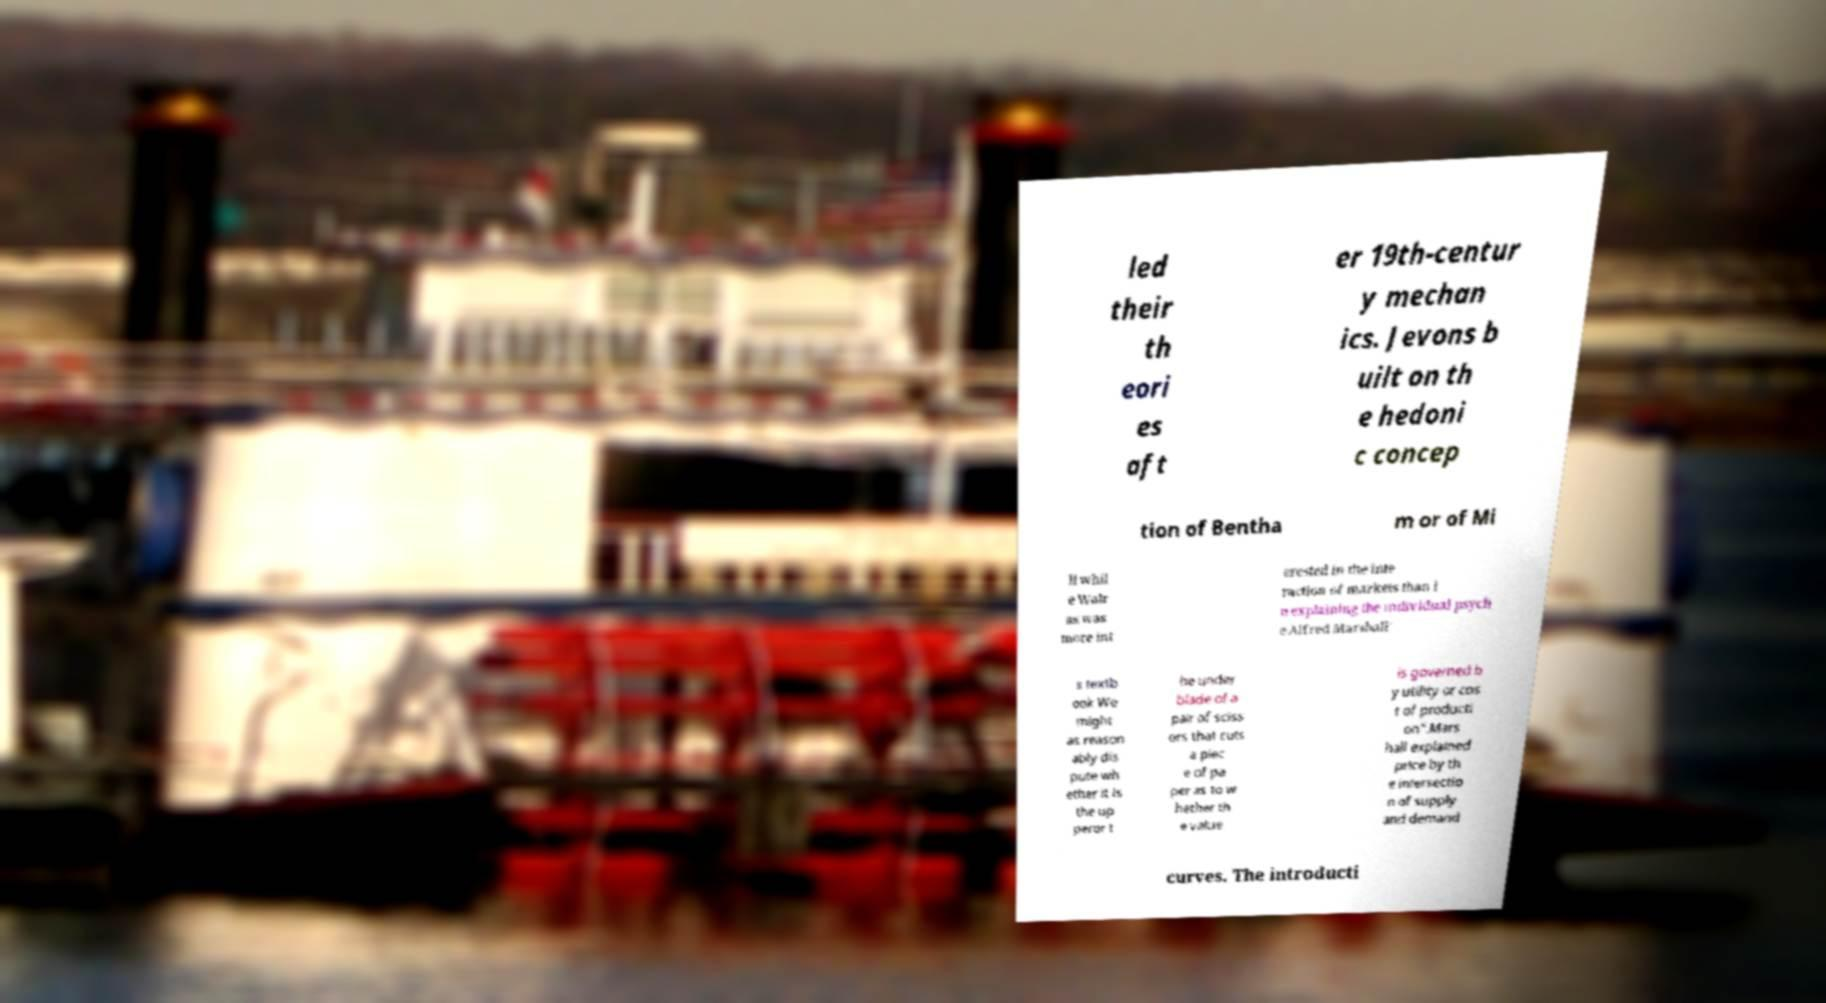Can you read and provide the text displayed in the image?This photo seems to have some interesting text. Can you extract and type it out for me? led their th eori es aft er 19th-centur y mechan ics. Jevons b uilt on th e hedoni c concep tion of Bentha m or of Mi ll whil e Walr as was more int erested in the inte raction of markets than i n explaining the individual psych e.Alfred Marshall' s textb ook We might as reason ably dis pute wh ether it is the up peror t he under blade of a pair of sciss ors that cuts a piec e of pa per as to w hether th e value is governed b y utility or cos t of producti on".Mars hall explained price by th e intersectio n of supply and demand curves. The introducti 